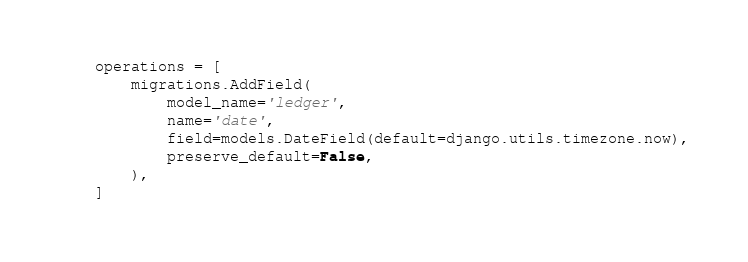<code> <loc_0><loc_0><loc_500><loc_500><_Python_>    operations = [
        migrations.AddField(
            model_name='ledger',
            name='date',
            field=models.DateField(default=django.utils.timezone.now),
            preserve_default=False,
        ),
    ]
</code> 